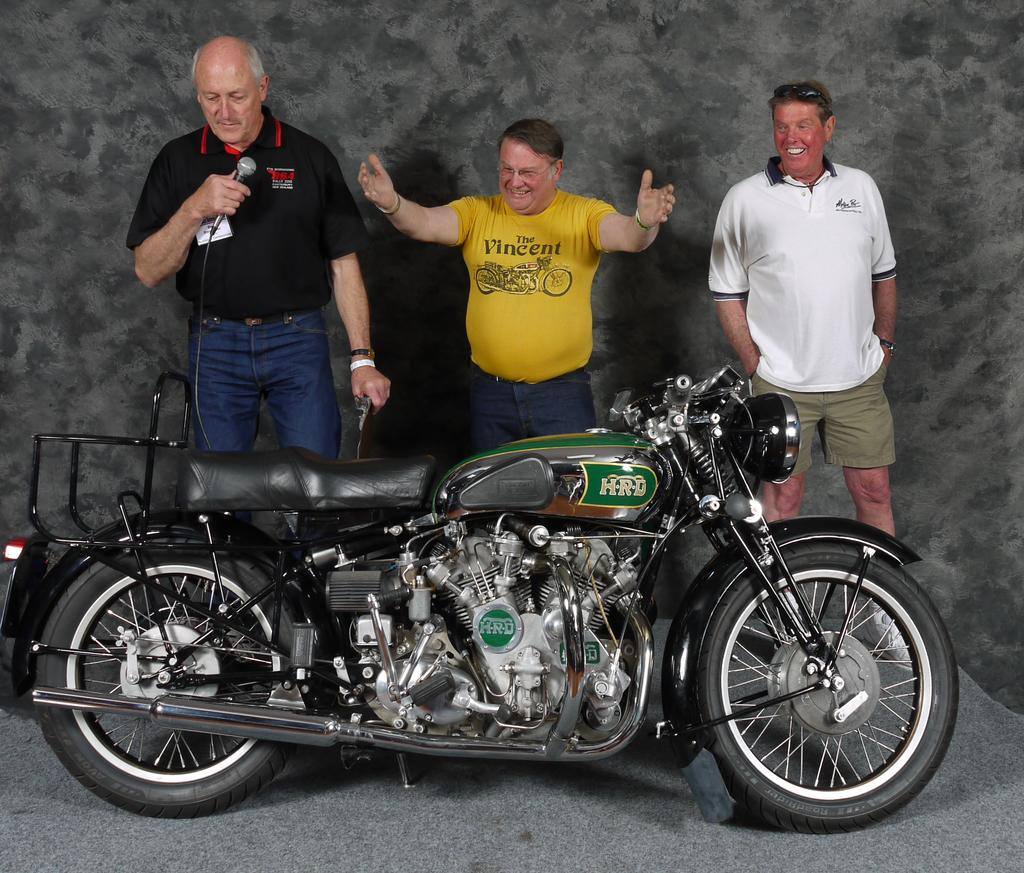How many people are in the image? There are people in the image, but the exact number is not specified. What type of vehicle is present in the image? There is a vehicle in the image, but its specific type is not mentioned. What is the person on the left side of the image holding? A person is holding an object in their hand on the left side of the image. How many fingers can be seen on the ground in the image? There is no mention of fingers on the ground in the image, so it cannot be determined from the facts. 